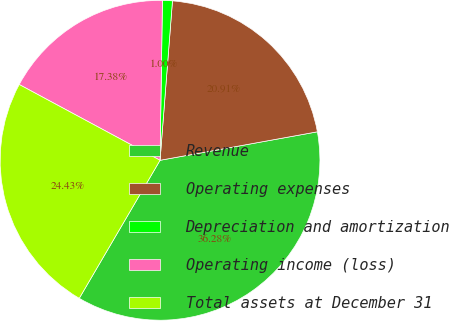Convert chart to OTSL. <chart><loc_0><loc_0><loc_500><loc_500><pie_chart><fcel>Revenue<fcel>Operating expenses<fcel>Depreciation and amortization<fcel>Operating income (loss)<fcel>Total assets at December 31<nl><fcel>36.28%<fcel>20.91%<fcel>1.0%<fcel>17.38%<fcel>24.43%<nl></chart> 